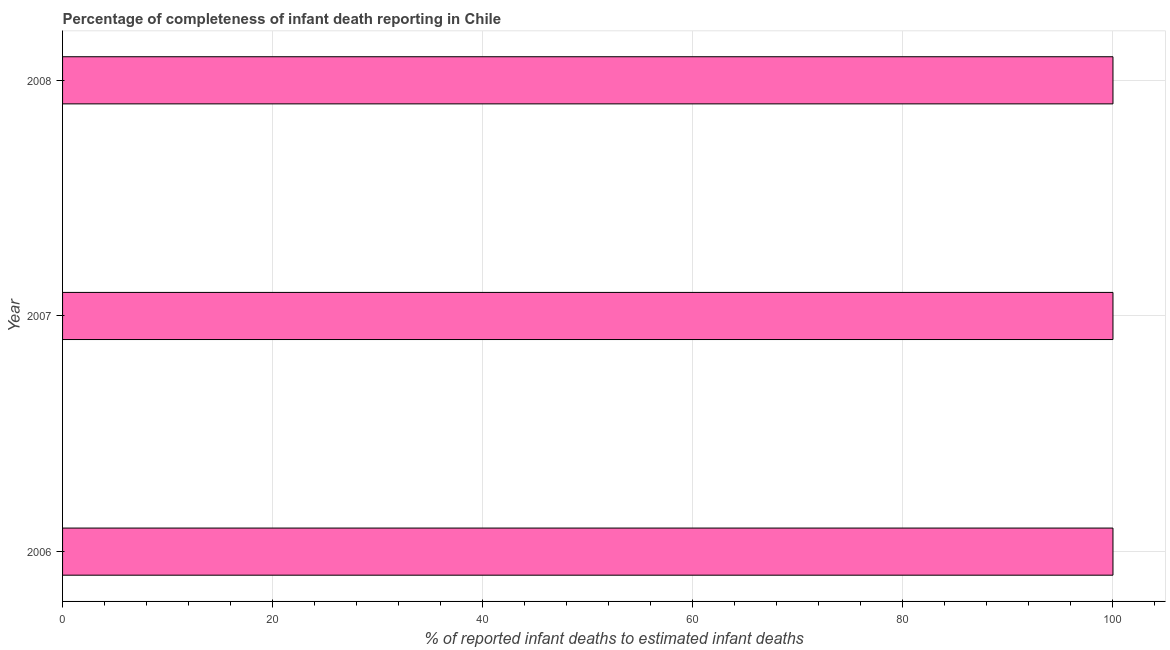What is the title of the graph?
Provide a succinct answer. Percentage of completeness of infant death reporting in Chile. What is the label or title of the X-axis?
Offer a terse response. % of reported infant deaths to estimated infant deaths. Across all years, what is the maximum completeness of infant death reporting?
Ensure brevity in your answer.  100. What is the sum of the completeness of infant death reporting?
Your response must be concise. 300. What is the average completeness of infant death reporting per year?
Provide a short and direct response. 100. What is the median completeness of infant death reporting?
Your answer should be compact. 100. In how many years, is the completeness of infant death reporting greater than 40 %?
Provide a succinct answer. 3. Do a majority of the years between 2008 and 2007 (inclusive) have completeness of infant death reporting greater than 88 %?
Provide a succinct answer. No. Is the completeness of infant death reporting in 2006 less than that in 2008?
Make the answer very short. No. Is the sum of the completeness of infant death reporting in 2006 and 2008 greater than the maximum completeness of infant death reporting across all years?
Provide a short and direct response. Yes. In how many years, is the completeness of infant death reporting greater than the average completeness of infant death reporting taken over all years?
Provide a short and direct response. 0. Are all the bars in the graph horizontal?
Give a very brief answer. Yes. How many years are there in the graph?
Keep it short and to the point. 3. Are the values on the major ticks of X-axis written in scientific E-notation?
Your answer should be compact. No. What is the % of reported infant deaths to estimated infant deaths of 2008?
Your response must be concise. 100. What is the difference between the % of reported infant deaths to estimated infant deaths in 2006 and 2007?
Your response must be concise. 0. What is the difference between the % of reported infant deaths to estimated infant deaths in 2006 and 2008?
Offer a terse response. 0. What is the ratio of the % of reported infant deaths to estimated infant deaths in 2006 to that in 2007?
Your response must be concise. 1. What is the ratio of the % of reported infant deaths to estimated infant deaths in 2006 to that in 2008?
Offer a terse response. 1. What is the ratio of the % of reported infant deaths to estimated infant deaths in 2007 to that in 2008?
Keep it short and to the point. 1. 